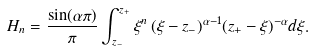<formula> <loc_0><loc_0><loc_500><loc_500>H _ { n } = \frac { \sin ( { \alpha \pi } ) } { \pi } \int _ { z _ { - } } ^ { z _ { + } } \xi ^ { n } \, ( \xi - z _ { - } ) ^ { \alpha - 1 } ( z _ { + } - \xi ) ^ { - \alpha } d \xi .</formula> 